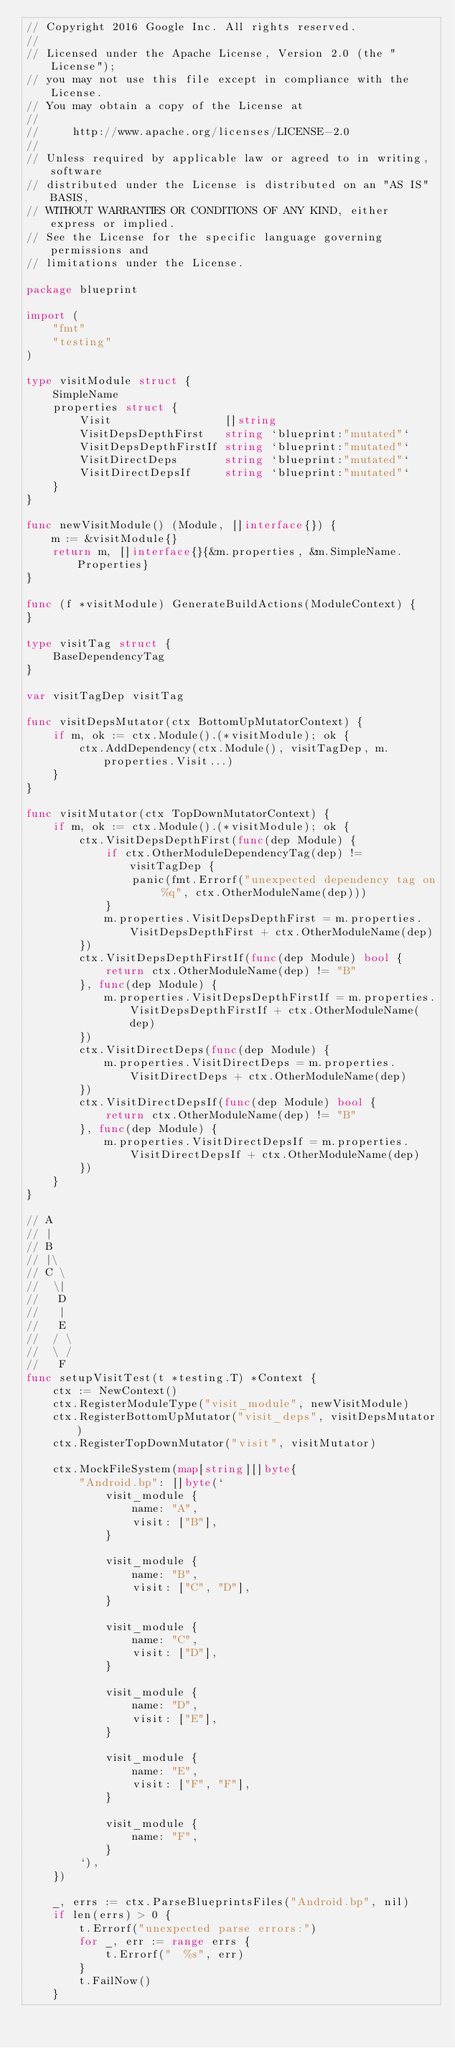Convert code to text. <code><loc_0><loc_0><loc_500><loc_500><_Go_>// Copyright 2016 Google Inc. All rights reserved.
//
// Licensed under the Apache License, Version 2.0 (the "License");
// you may not use this file except in compliance with the License.
// You may obtain a copy of the License at
//
//     http://www.apache.org/licenses/LICENSE-2.0
//
// Unless required by applicable law or agreed to in writing, software
// distributed under the License is distributed on an "AS IS" BASIS,
// WITHOUT WARRANTIES OR CONDITIONS OF ANY KIND, either express or implied.
// See the License for the specific language governing permissions and
// limitations under the License.

package blueprint

import (
	"fmt"
	"testing"
)

type visitModule struct {
	SimpleName
	properties struct {
		Visit                 []string
		VisitDepsDepthFirst   string `blueprint:"mutated"`
		VisitDepsDepthFirstIf string `blueprint:"mutated"`
		VisitDirectDeps       string `blueprint:"mutated"`
		VisitDirectDepsIf     string `blueprint:"mutated"`
	}
}

func newVisitModule() (Module, []interface{}) {
	m := &visitModule{}
	return m, []interface{}{&m.properties, &m.SimpleName.Properties}
}

func (f *visitModule) GenerateBuildActions(ModuleContext) {
}

type visitTag struct {
	BaseDependencyTag
}

var visitTagDep visitTag

func visitDepsMutator(ctx BottomUpMutatorContext) {
	if m, ok := ctx.Module().(*visitModule); ok {
		ctx.AddDependency(ctx.Module(), visitTagDep, m.properties.Visit...)
	}
}

func visitMutator(ctx TopDownMutatorContext) {
	if m, ok := ctx.Module().(*visitModule); ok {
		ctx.VisitDepsDepthFirst(func(dep Module) {
			if ctx.OtherModuleDependencyTag(dep) != visitTagDep {
				panic(fmt.Errorf("unexpected dependency tag on %q", ctx.OtherModuleName(dep)))
			}
			m.properties.VisitDepsDepthFirst = m.properties.VisitDepsDepthFirst + ctx.OtherModuleName(dep)
		})
		ctx.VisitDepsDepthFirstIf(func(dep Module) bool {
			return ctx.OtherModuleName(dep) != "B"
		}, func(dep Module) {
			m.properties.VisitDepsDepthFirstIf = m.properties.VisitDepsDepthFirstIf + ctx.OtherModuleName(dep)
		})
		ctx.VisitDirectDeps(func(dep Module) {
			m.properties.VisitDirectDeps = m.properties.VisitDirectDeps + ctx.OtherModuleName(dep)
		})
		ctx.VisitDirectDepsIf(func(dep Module) bool {
			return ctx.OtherModuleName(dep) != "B"
		}, func(dep Module) {
			m.properties.VisitDirectDepsIf = m.properties.VisitDirectDepsIf + ctx.OtherModuleName(dep)
		})
	}
}

// A
// |
// B
// |\
// C \
//  \|
//   D
//   |
//   E
//  / \
//  \ /
//   F
func setupVisitTest(t *testing.T) *Context {
	ctx := NewContext()
	ctx.RegisterModuleType("visit_module", newVisitModule)
	ctx.RegisterBottomUpMutator("visit_deps", visitDepsMutator)
	ctx.RegisterTopDownMutator("visit", visitMutator)

	ctx.MockFileSystem(map[string][]byte{
		"Android.bp": []byte(`
			visit_module {
				name: "A",
				visit: ["B"],
			}
	
			visit_module {
				name: "B",
				visit: ["C", "D"],
			}
	
			visit_module {
				name: "C",
				visit: ["D"],
			}
	
			visit_module {
				name: "D",
				visit: ["E"],
			}
	
			visit_module {
				name: "E",
				visit: ["F", "F"],
			}

			visit_module {
				name: "F",
			}
		`),
	})

	_, errs := ctx.ParseBlueprintsFiles("Android.bp", nil)
	if len(errs) > 0 {
		t.Errorf("unexpected parse errors:")
		for _, err := range errs {
			t.Errorf("  %s", err)
		}
		t.FailNow()
	}
</code> 